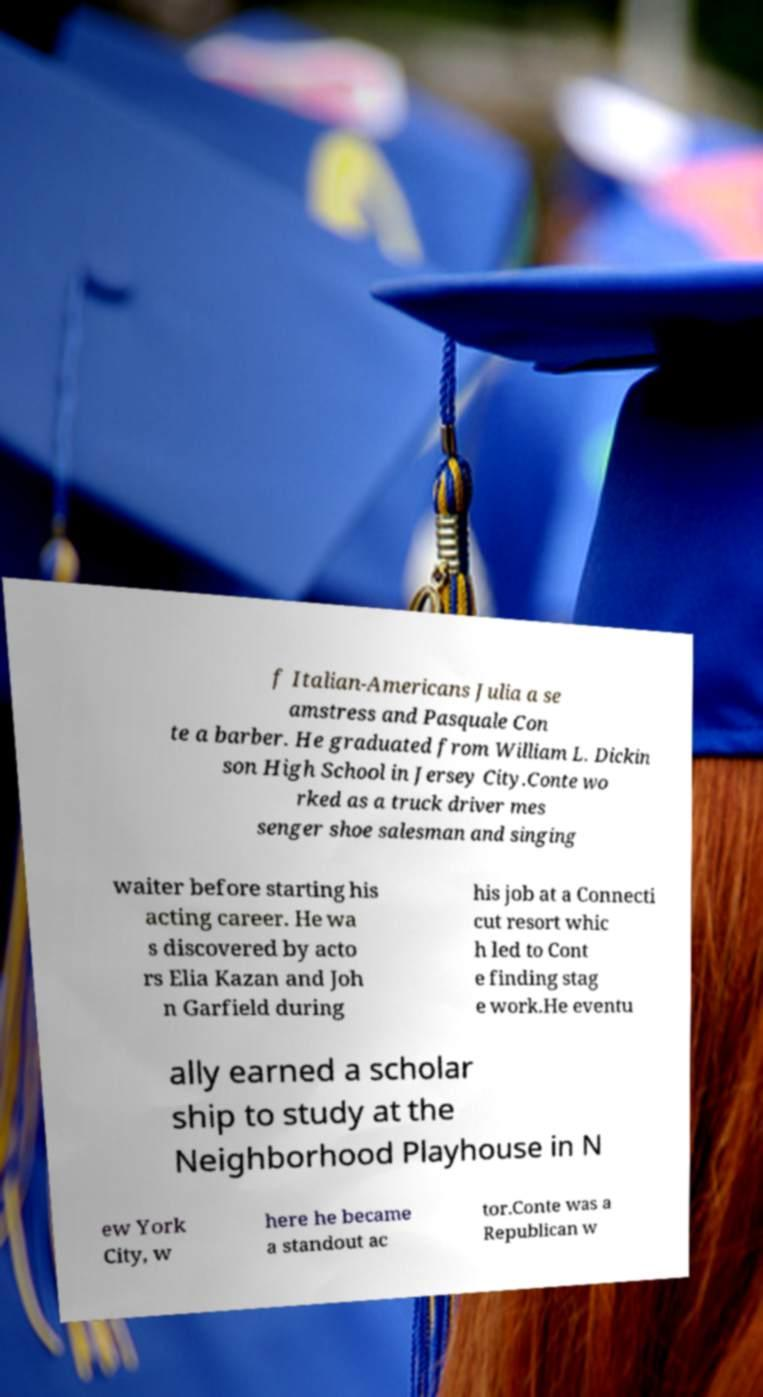What messages or text are displayed in this image? I need them in a readable, typed format. f Italian-Americans Julia a se amstress and Pasquale Con te a barber. He graduated from William L. Dickin son High School in Jersey City.Conte wo rked as a truck driver mes senger shoe salesman and singing waiter before starting his acting career. He wa s discovered by acto rs Elia Kazan and Joh n Garfield during his job at a Connecti cut resort whic h led to Cont e finding stag e work.He eventu ally earned a scholar ship to study at the Neighborhood Playhouse in N ew York City, w here he became a standout ac tor.Conte was a Republican w 